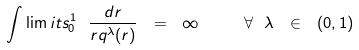Convert formula to latex. <formula><loc_0><loc_0><loc_500><loc_500>\int \lim i t s _ { 0 } ^ { 1 } \ \frac { d r } { r q ^ { \lambda } ( r ) } \ = \ \infty \quad \ \forall \ \lambda \ \in \ ( 0 , 1 )</formula> 